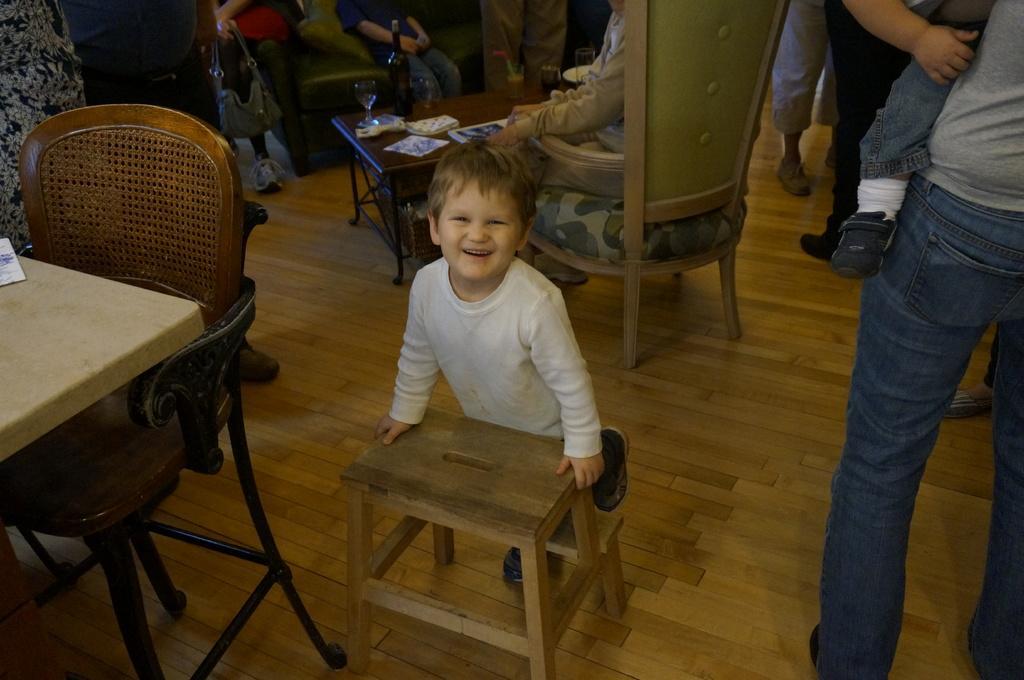How would you summarize this image in a sentence or two? The picture is taken in a room where in the center of the picture a boy is holding a table and at the right corner of the picture a person is carrying a baby and in the middle of the picture a person is sitting on the chair and in front there is a table where bottle and glasses are on it, at the left corner of the picture there is one table and chair, behind that there are people standing and one person is carrying a bag and there is a sofa people are sitting on it. 